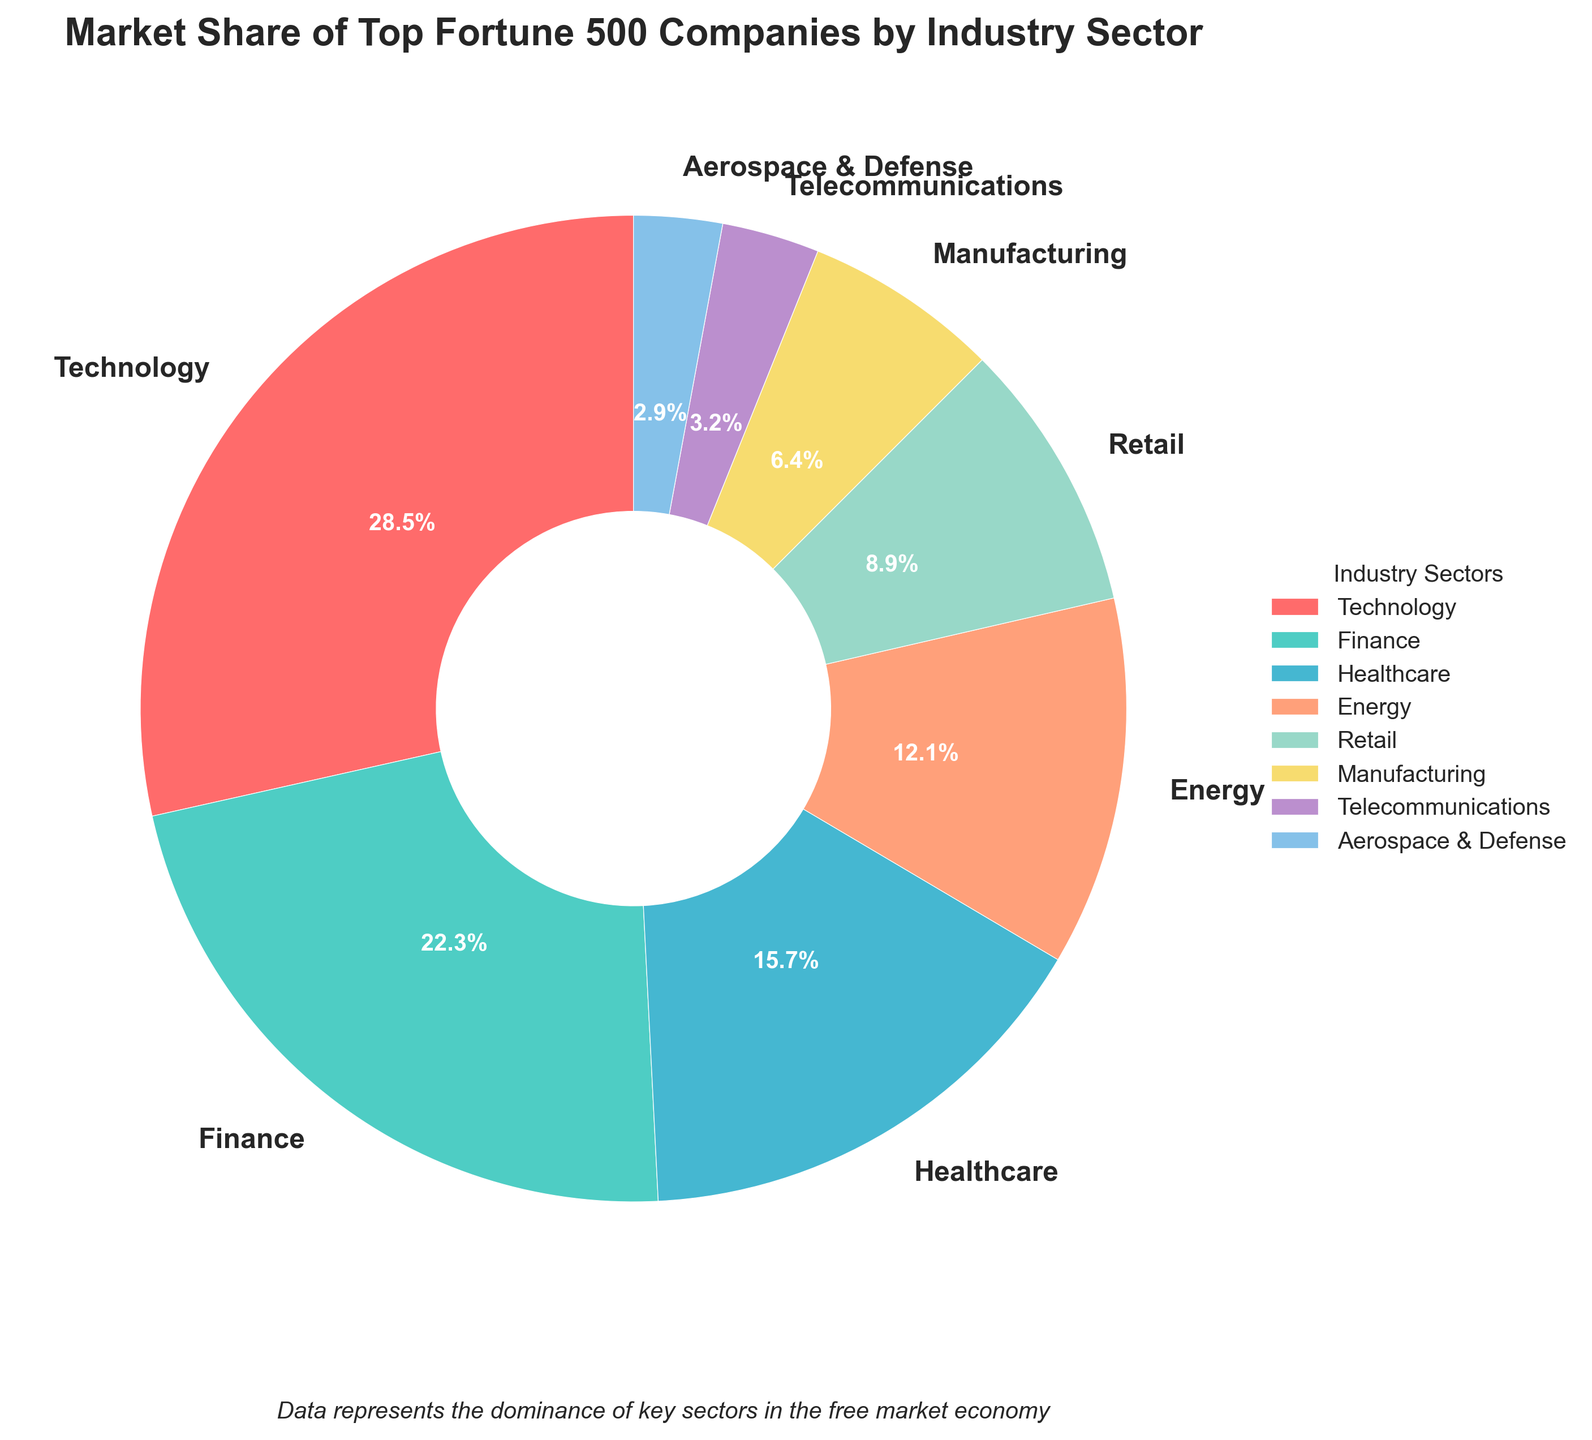What percentage of the market share is held by the Finance and Retail sectors combined? To find the combined market share of the Finance and Retail sectors, add the respective shares: 22.3 (Finance) + 8.9 (Retail) = 31.2.
Answer: 31.2% Which industry sector holds the smallest market share? The smallest market share is held by the Aerospace & Defense sector, with a share of 2.9%.
Answer: Aerospace & Defense Is the market share of the Technology sector greater than the combined market share of the Healthcare and Energy sectors? The Technology sector has a market share of 28.5%. The combined market share of the Healthcare and Energy sectors is 15.7 (Healthcare) + 12.1 (Energy) = 27.8. Since 28.5 is greater than 27.8, the Technology sector's market share is indeed greater.
Answer: Yes How does the market share of the Technology sector compare to the Manufacturing sector? The market share of the Technology sector (28.5%) is significantly greater than that of the Manufacturing sector (6.4%).
Answer: Technology has a greater share Which industry sector is represented by the red color in the pie chart? Observing the color assignments, the sector represented by the red wedge in the pie chart is the Technology sector.
Answer: Technology What is the difference in market share between the Finance sector and the Energy sector? To find the difference, subtract the Energy sector's share from the Finance sector's share: 22.3 (Finance) - 12.1 (Energy) = 10.2.
Answer: 10.2% If you sum the market shares of the Telecommunications and Aerospace & Defense sectors, do they exceed the Retail sector's market share? The combined market share of the Telecommunications and Aerospace & Defense sectors is 3.2 (Telecommunications) + 2.9 (Aerospace & Defense) = 6.1. This is less than the Retail sector's market share of 8.9%.
Answer: No What is the average market share of the top three industry sectors? The top three industry sectors are Technology (28.5%), Finance (22.3%), and Healthcare (15.7%). The average market share is calculated by summing these values and dividing by 3: (28.5 + 22.3 + 15.7) / 3 = 22.17.
Answer: 22.17% What percentage of the market share is not covered by the top four industry sectors (Technology, Finance, Healthcare, Energy)? The total market share of the top four sectors is 28.5 (Technology) + 22.3 (Finance) + 15.7 (Healthcare) + 12.1 (Energy) = 78.6. This means the percentage of the market not covered is 100 - 78.6 = 21.4.
Answer: 21.4% 